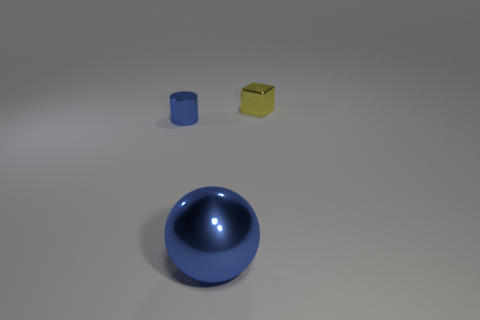Add 2 large red matte spheres. How many objects exist? 5 Subtract all balls. How many objects are left? 2 Add 1 tiny blue blocks. How many tiny blue blocks exist? 1 Subtract 0 green cylinders. How many objects are left? 3 Subtract all small yellow things. Subtract all tiny purple matte blocks. How many objects are left? 2 Add 1 cubes. How many cubes are left? 2 